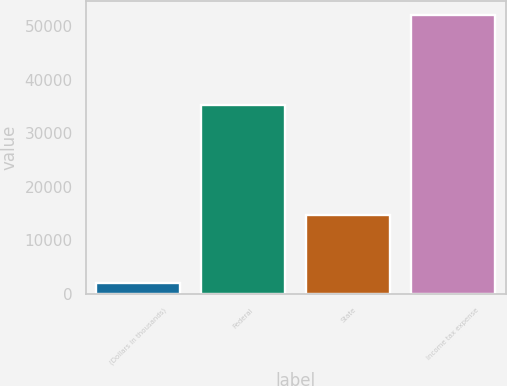Convert chart. <chart><loc_0><loc_0><loc_500><loc_500><bar_chart><fcel>(Dollars in thousands)<fcel>Federal<fcel>State<fcel>Income tax expense<nl><fcel>2008<fcel>35358<fcel>14640<fcel>52213<nl></chart> 